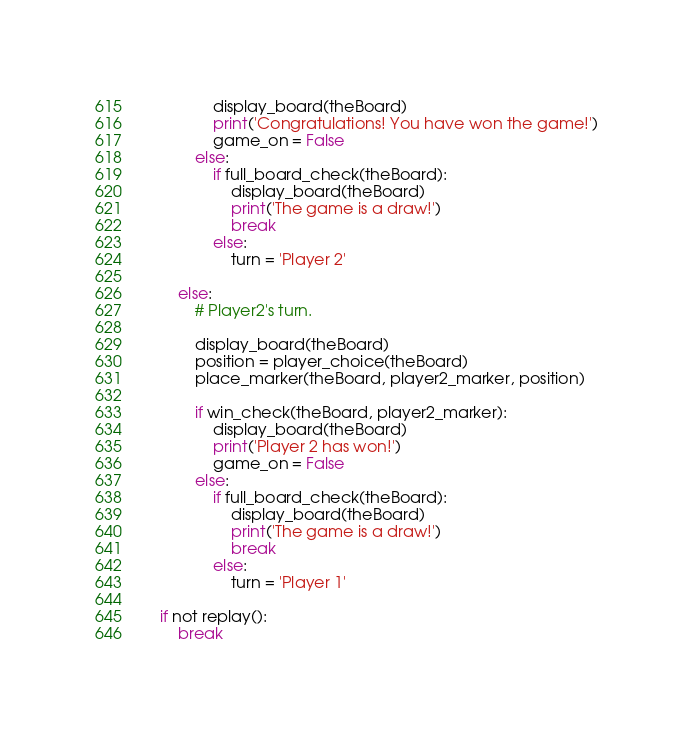Convert code to text. <code><loc_0><loc_0><loc_500><loc_500><_Python_>                display_board(theBoard)
                print('Congratulations! You have won the game!')
                game_on = False
            else:
                if full_board_check(theBoard):
                    display_board(theBoard)
                    print('The game is a draw!')
                    break
                else:
                    turn = 'Player 2'

        else:
            # Player2's turn.
            
            display_board(theBoard)
            position = player_choice(theBoard)
            place_marker(theBoard, player2_marker, position)

            if win_check(theBoard, player2_marker):
                display_board(theBoard)
                print('Player 2 has won!')
                game_on = False
            else:
                if full_board_check(theBoard):
                    display_board(theBoard)
                    print('The game is a draw!')
                    break
                else:
                    turn = 'Player 1'

    if not replay():
        break</code> 